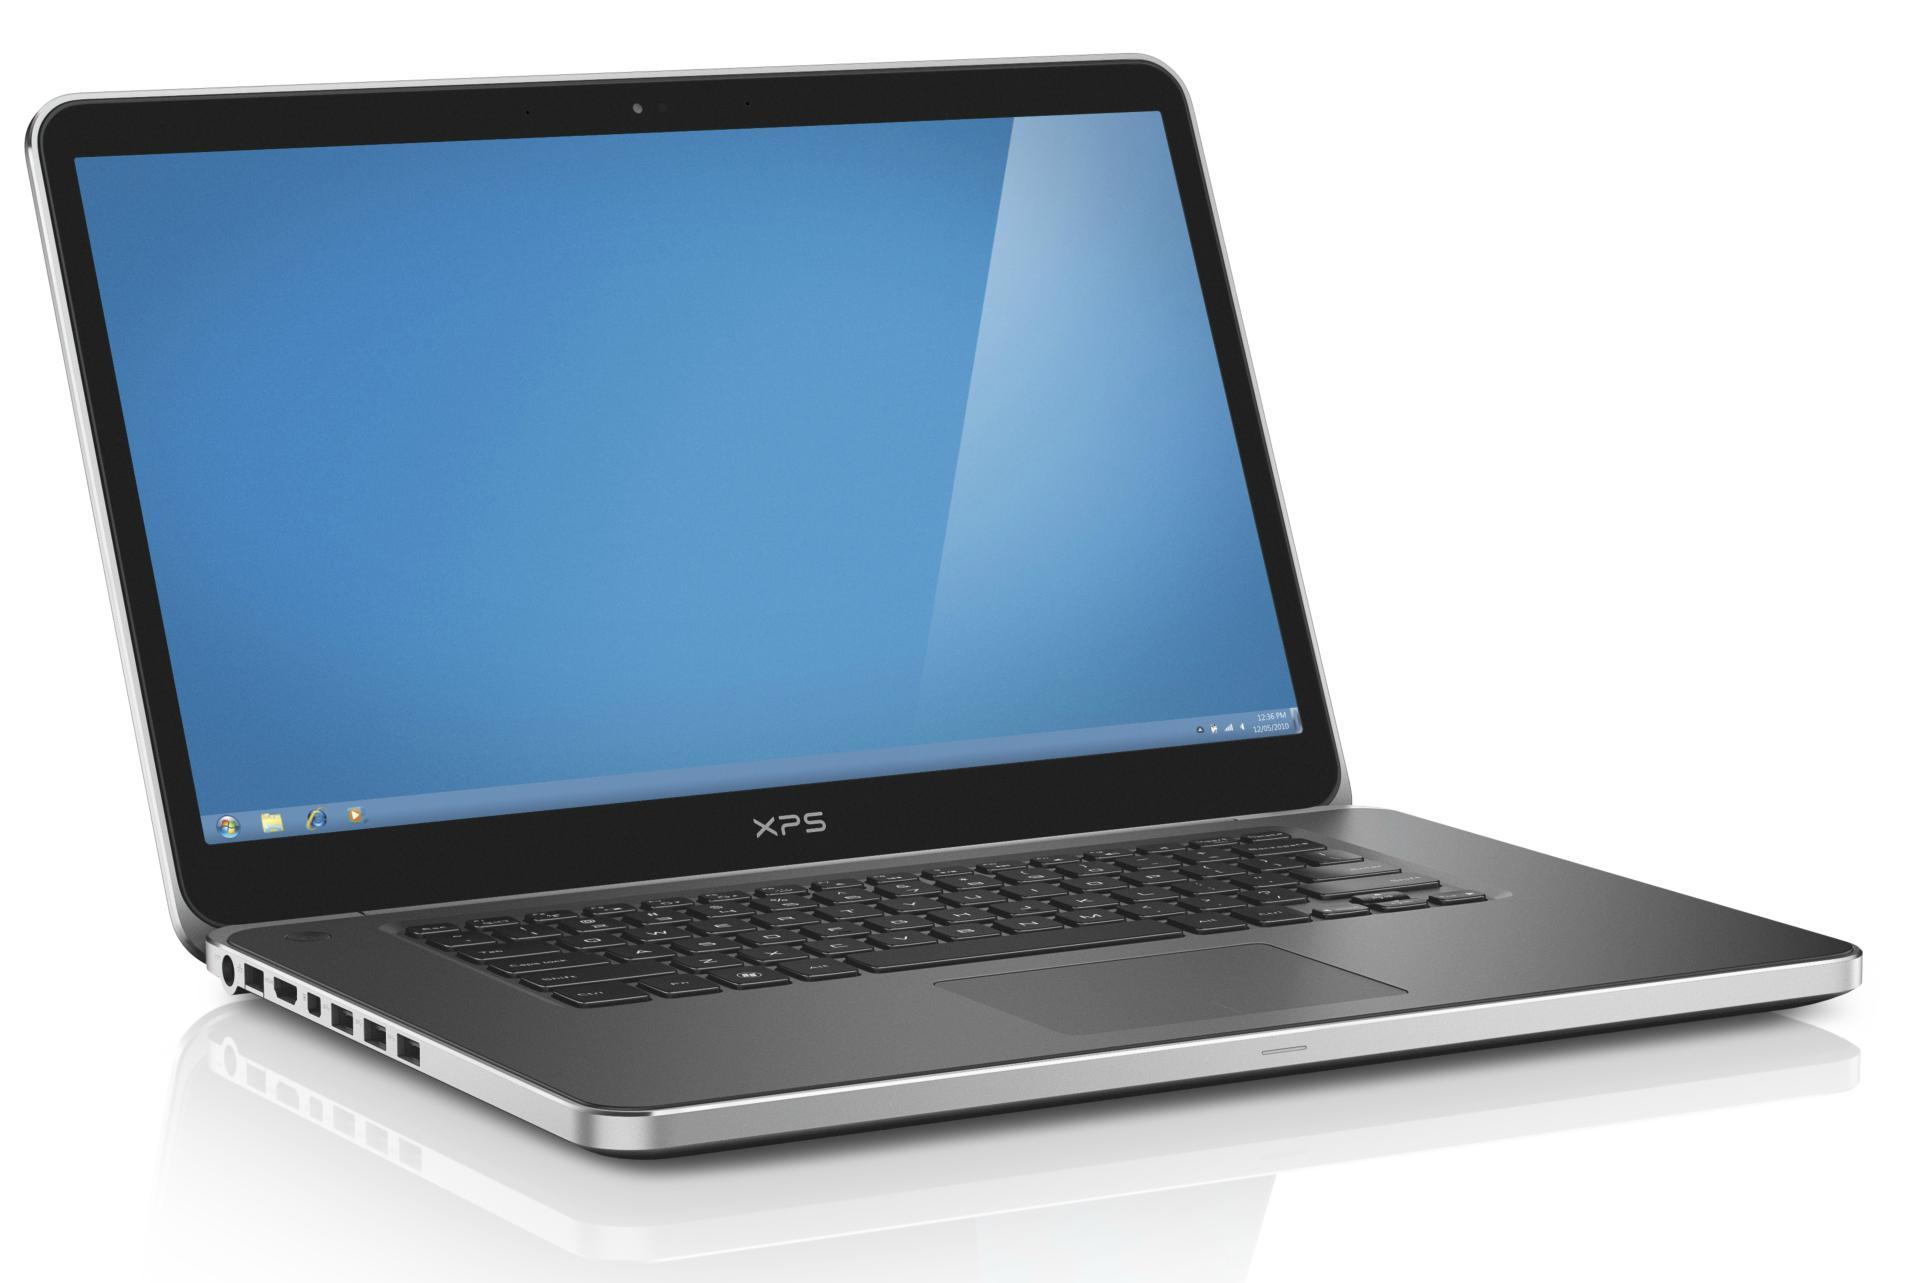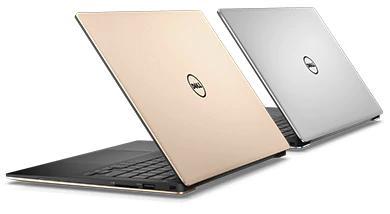The first image is the image on the left, the second image is the image on the right. For the images displayed, is the sentence "The computer screen is visible in at least one of the images." factually correct? Answer yes or no. Yes. The first image is the image on the left, the second image is the image on the right. Analyze the images presented: Is the assertion "Each image contains only one laptop, and all laptops are open at less than a 90-degree angle and facing the same general direction." valid? Answer yes or no. No. 